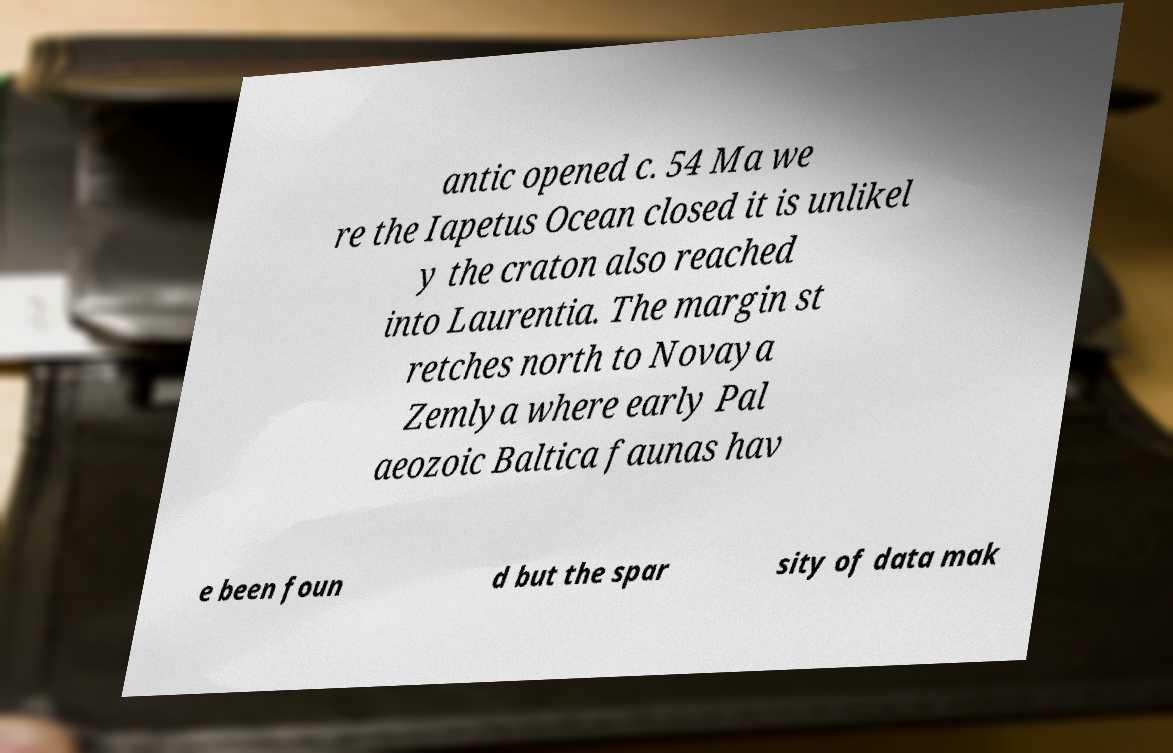Please identify and transcribe the text found in this image. antic opened c. 54 Ma we re the Iapetus Ocean closed it is unlikel y the craton also reached into Laurentia. The margin st retches north to Novaya Zemlya where early Pal aeozoic Baltica faunas hav e been foun d but the spar sity of data mak 